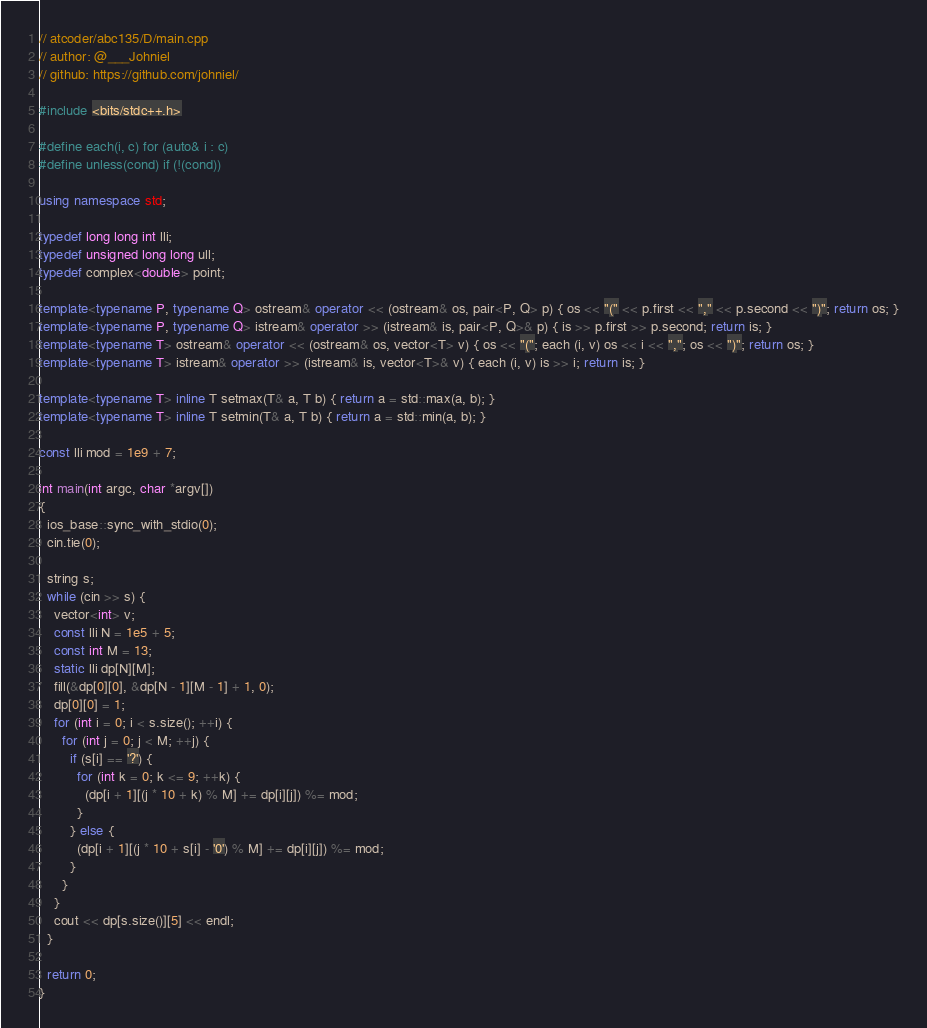<code> <loc_0><loc_0><loc_500><loc_500><_C++_>// atcoder/abc135/D/main.cpp
// author: @___Johniel
// github: https://github.com/johniel/

#include <bits/stdc++.h>

#define each(i, c) for (auto& i : c)
#define unless(cond) if (!(cond))

using namespace std;

typedef long long int lli;
typedef unsigned long long ull;
typedef complex<double> point;

template<typename P, typename Q> ostream& operator << (ostream& os, pair<P, Q> p) { os << "(" << p.first << "," << p.second << ")"; return os; }
template<typename P, typename Q> istream& operator >> (istream& is, pair<P, Q>& p) { is >> p.first >> p.second; return is; }
template<typename T> ostream& operator << (ostream& os, vector<T> v) { os << "("; each (i, v) os << i << ","; os << ")"; return os; }
template<typename T> istream& operator >> (istream& is, vector<T>& v) { each (i, v) is >> i; return is; }

template<typename T> inline T setmax(T& a, T b) { return a = std::max(a, b); }
template<typename T> inline T setmin(T& a, T b) { return a = std::min(a, b); }

const lli mod = 1e9 + 7;

int main(int argc, char *argv[])
{
  ios_base::sync_with_stdio(0);
  cin.tie(0);

  string s;
  while (cin >> s) {
    vector<int> v;
    const lli N = 1e5 + 5;
    const int M = 13;
    static lli dp[N][M];
    fill(&dp[0][0], &dp[N - 1][M - 1] + 1, 0);
    dp[0][0] = 1;
    for (int i = 0; i < s.size(); ++i) {
      for (int j = 0; j < M; ++j) {
        if (s[i] == '?') {
          for (int k = 0; k <= 9; ++k) {
            (dp[i + 1][(j * 10 + k) % M] += dp[i][j]) %= mod;
          }
        } else {
          (dp[i + 1][(j * 10 + s[i] - '0') % M] += dp[i][j]) %= mod;
        }
      }
    }
    cout << dp[s.size()][5] << endl;
  }

  return 0;
}
</code> 